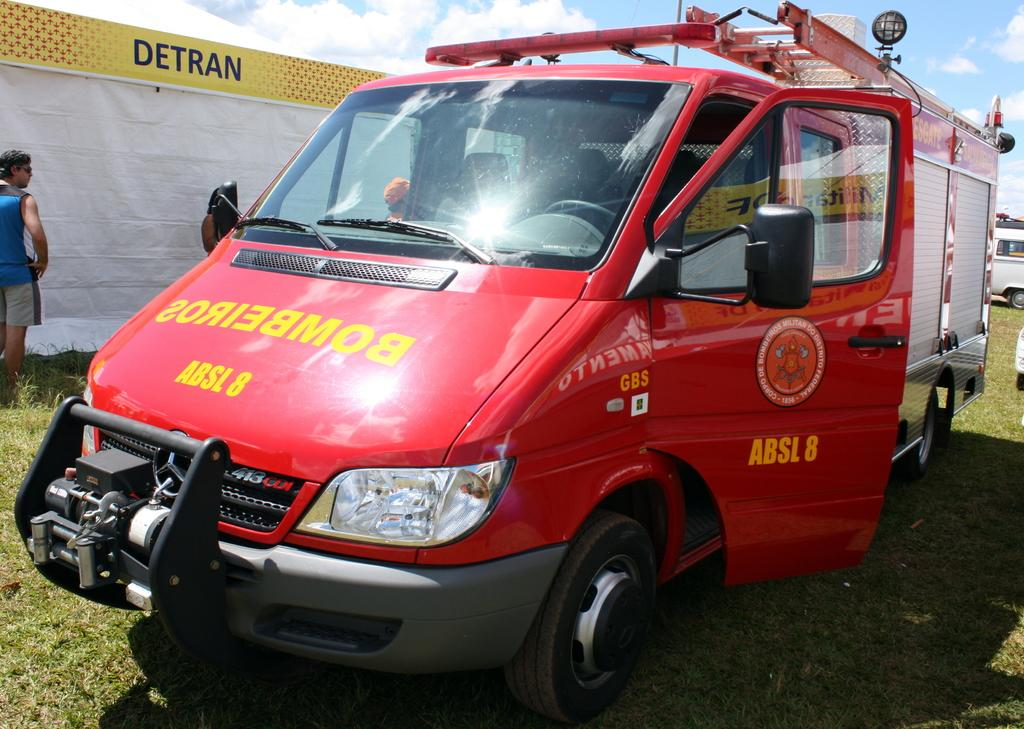<image>
Provide a brief description of the given image. An ambulance is parked in front of a building with Detran on it. 